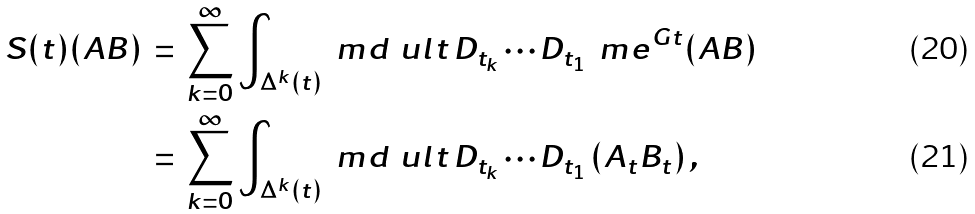Convert formula to latex. <formula><loc_0><loc_0><loc_500><loc_500>S ( t ) ( A B ) & \, = \, \sum _ { k = 0 } ^ { \infty } \int _ { \Delta ^ { k } ( t ) } \ m d \ u l { t } \, D _ { t _ { k } } \cdots D _ { t _ { 1 } } \, \ m e ^ { G t } ( A B ) \\ & \, = \, \sum _ { k = 0 } ^ { \infty } \int _ { \Delta ^ { k } ( t ) } \ m d \ u l { t } \, D _ { t _ { k } } \cdots D _ { t _ { 1 } } \, ( A _ { t } B _ { t } ) \, ,</formula> 